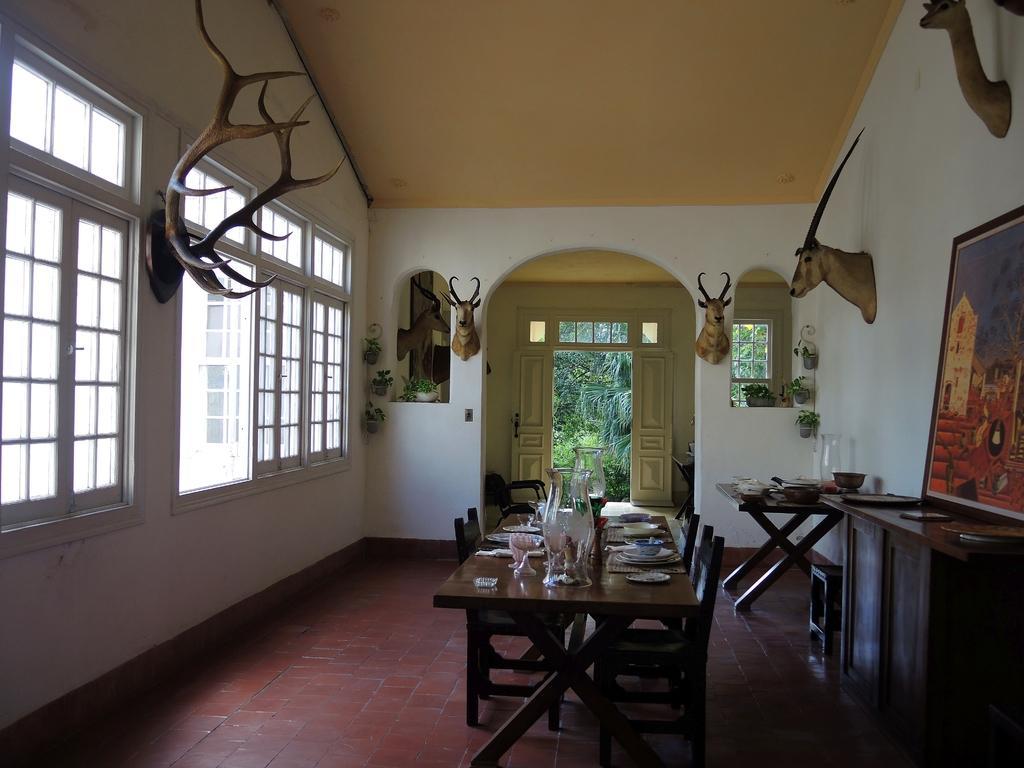How would you summarize this image in a sentence or two? In the foreground, I can see tables on which a photo frame, plates, bowls, glasses and glass objects are kept. In the background, I can see windows, door, a wall, sculptures, house plants and trees. This image taken, maybe in a hall. 